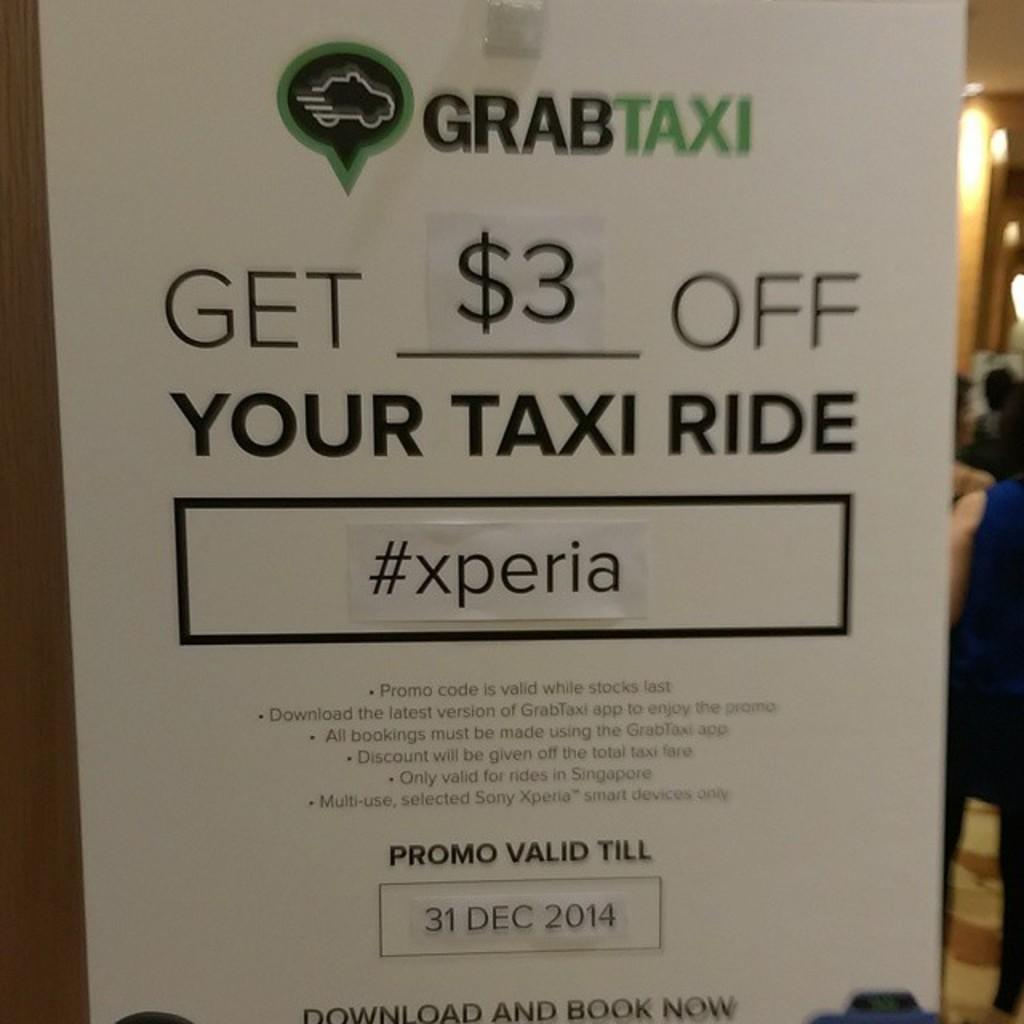<image>
Write a terse but informative summary of the picture. a poster that says 'grabtaxi' on the top of it 